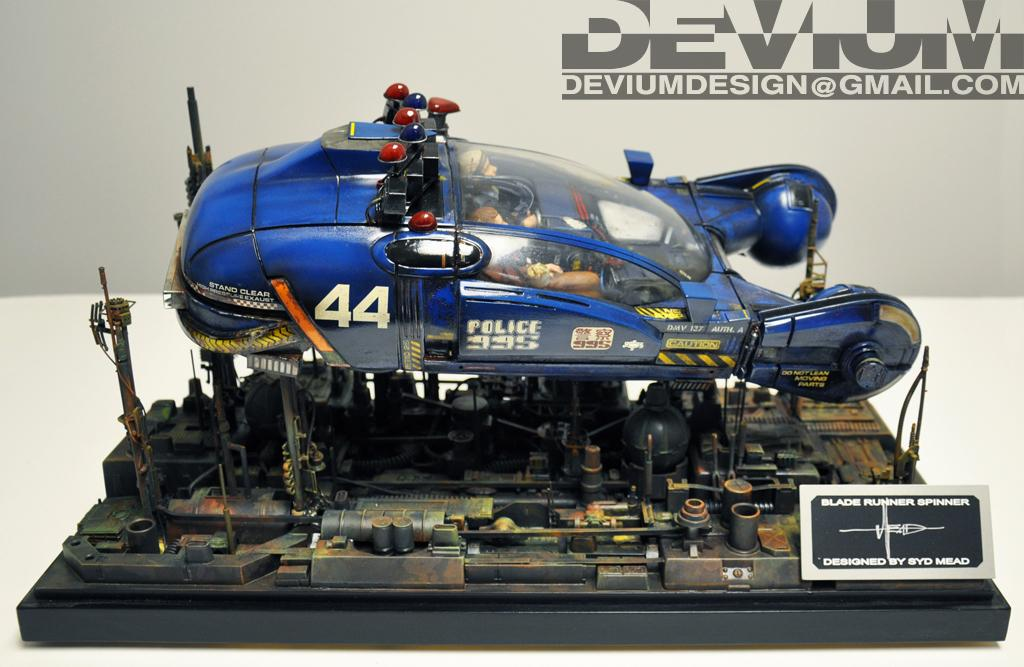What is the main subject of the image? The main subject of the image is an airplane toy. Can you describe the background of the image? There is a wall in the background of the image. What type of nose can be seen on the airplane toy in the image? There is no nose present on the airplane toy in the image, as it is a toy and not a real airplane. 